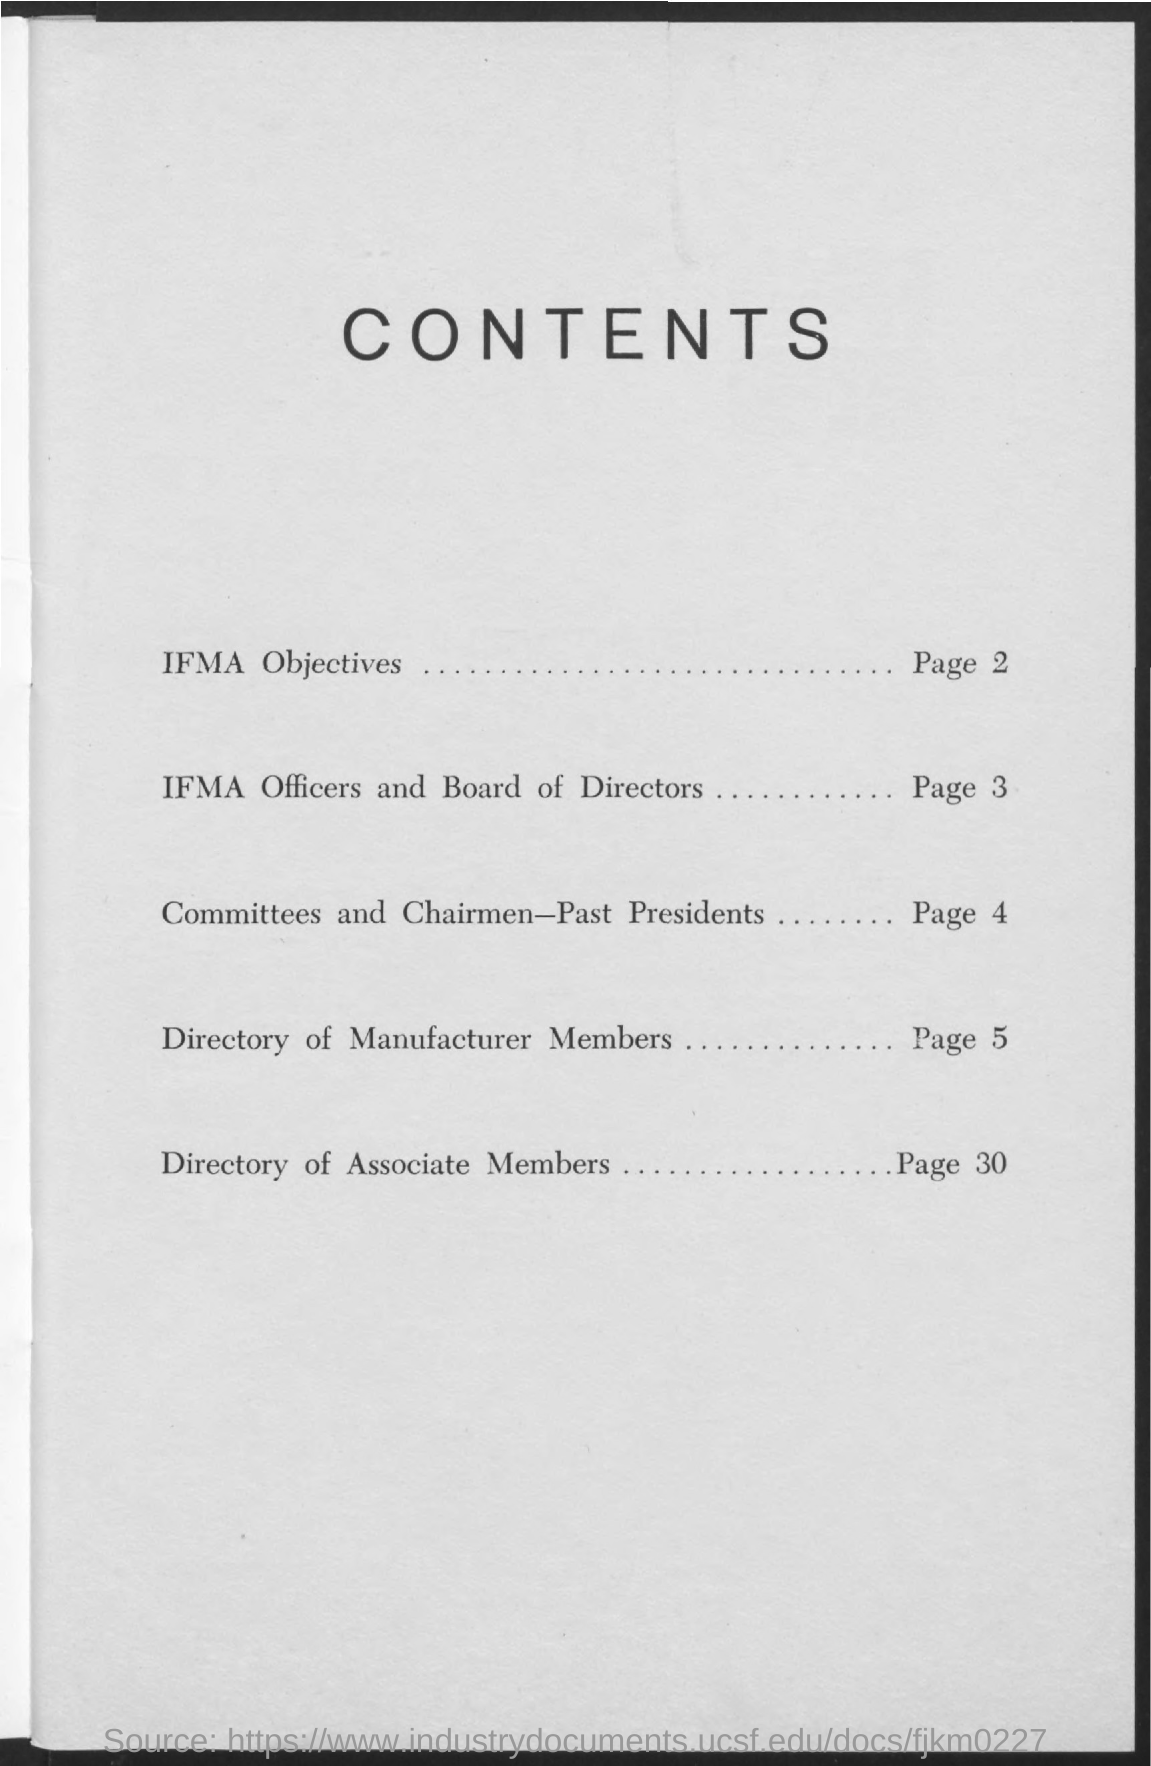What are the contents in page 2 ?
Provide a short and direct response. IFMA Objectives. What are the contents in page 30 ?
Offer a terse response. DIRECTORY OF ASSOCIATE MEMBERS. On which page the directory of manufacturer members were given ?
Your answer should be compact. Page 5. What are the contents in page 3 ?
Your answer should be compact. IFMA OFFICERS AND BOARD OF DIRECTORS. 